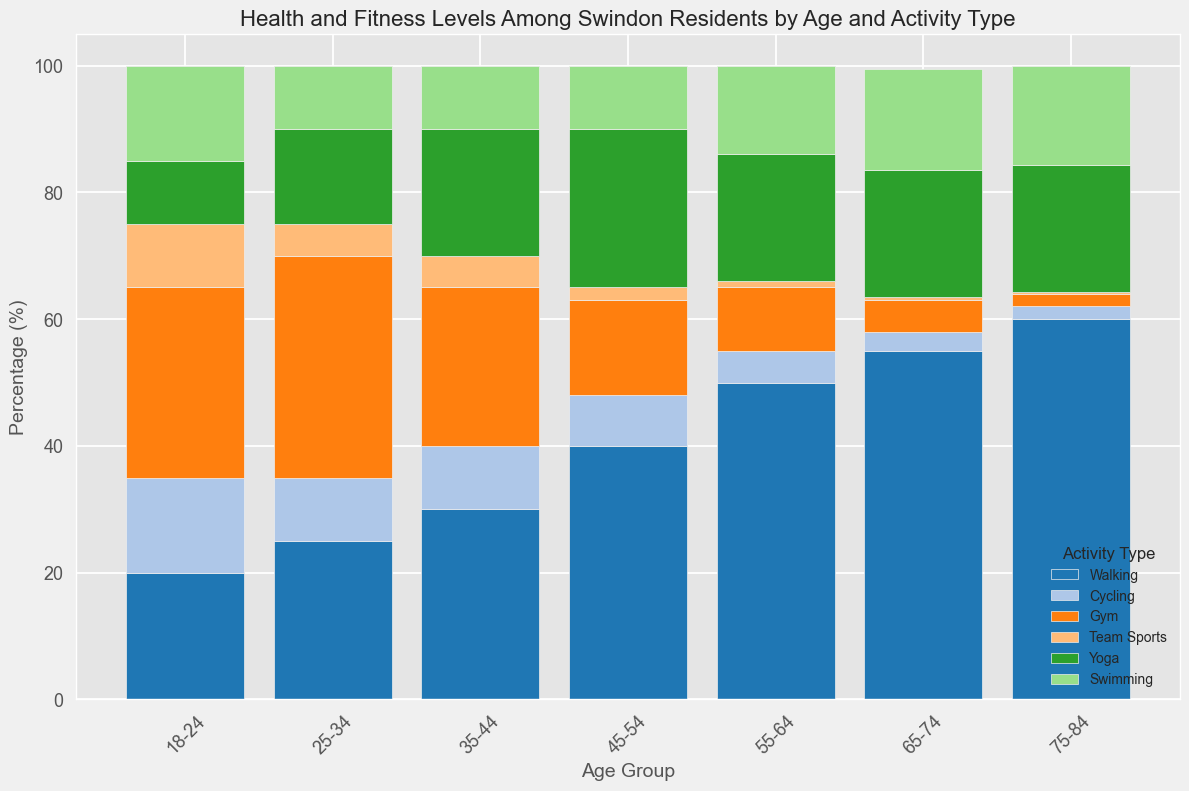What is the most popular activity type among the 25-34 age group? By looking at the bars in the '25-34' age group, the 'Gym' activity has the highest percentage.
Answer: Gym Compare the popularity of walking between the 18-24 and 75-84 age groups. In the '18-24' age group, walking is at 20%, whereas in the '75-84' age group, it is at 60%.
Answer: Walking is more popular in the 75-84 age group Which age group has the highest percentage of people participating in team sports? By inspecting the height of the bars for team sports across age groups, the '18-24' age group has the highest percentage at 10%.
Answer: 18-24 What is the combined percentage of walking and gym activities in the 35-44 age group? In the '35-44' age group, walking is at 30% and gym is at 25%. Summing them up gives 30% + 25% = 55%.
Answer: 55% How does the percentage of cycling vary from 18-24 to 65-74 age groups? The percentages of cycling for 18-24, 25-34, 35-44, 45-54, 55-64, and 65-74 age groups are 15%, 10%, 10%, 8%, 5%, and 3%, respectively. The trend shows a reduction in percentage as the age increases.
Answer: The percentage decreases with age Which activity type maintains a nearly constant percentage across all age groups? By observing the bars for all age groups, 'Yoga' activity type has a consistent percentage close to 20%.
Answer: Yoga What is the total percentage for all activities in the 55-64 age group? Summing up the percentages for walking (50%), cycling (5%), gym (10%), team sports (1%), yoga (20%), and swimming (14%) gives 50% + 5% + 10% + 1% + 20% + 14% = 100%.
Answer: 100% In which age group is swimming least popular? By comparing the height of the bars for swimming across all age groups, the '25-34' age group has the lowest percentage at 10%.
Answer: 25-34 